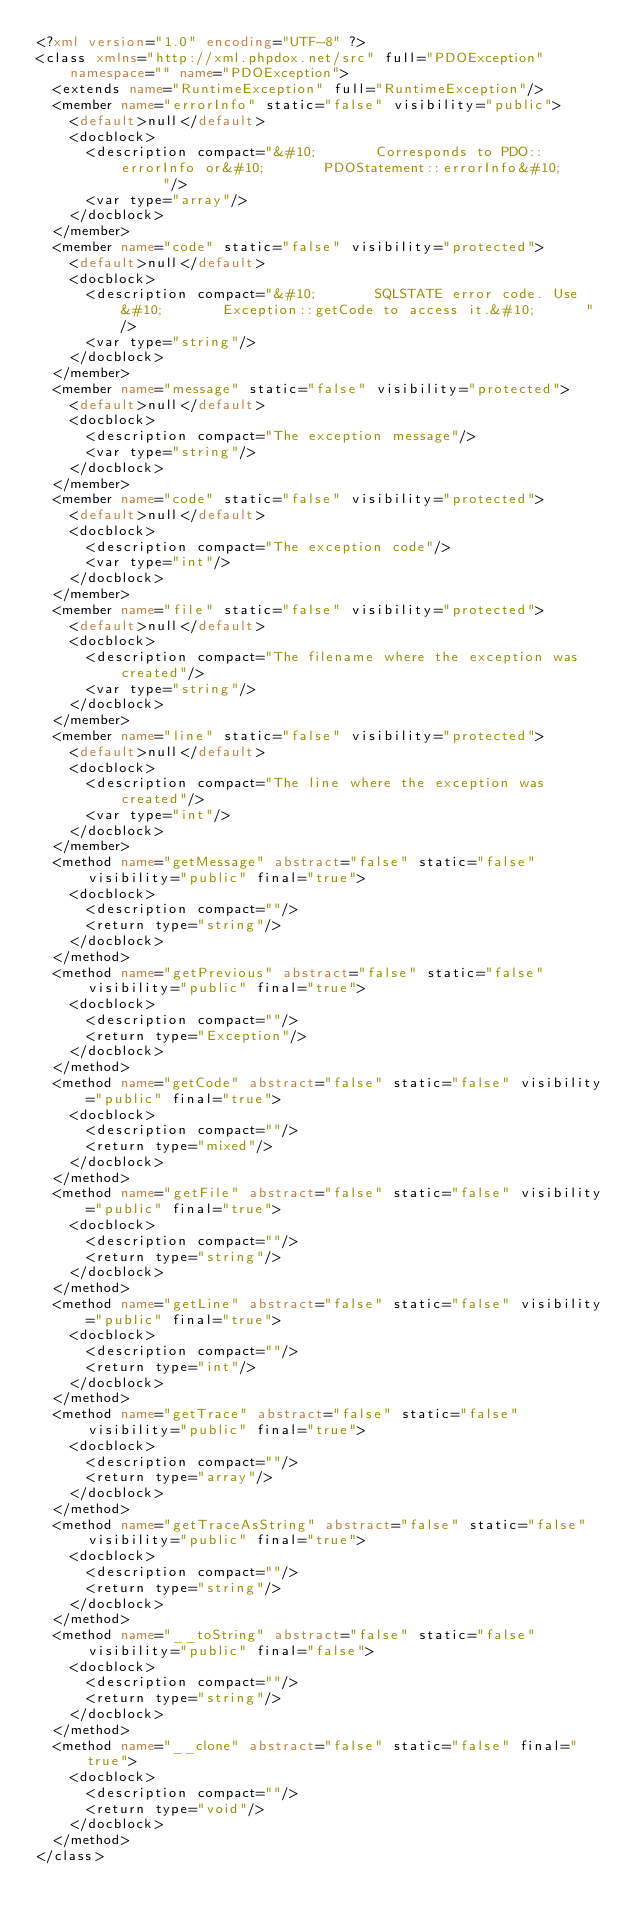Convert code to text. <code><loc_0><loc_0><loc_500><loc_500><_XML_><?xml version="1.0" encoding="UTF-8" ?>
<class xmlns="http://xml.phpdox.net/src" full="PDOException" namespace="" name="PDOException">
  <extends name="RuntimeException" full="RuntimeException"/>
  <member name="errorInfo" static="false" visibility="public">
    <default>null</default>
    <docblock>
      <description compact="&#10;       Corresponds to PDO::errorInfo or&#10;       PDOStatement::errorInfo&#10;      "/>
      <var type="array"/>
    </docblock>
  </member>
  <member name="code" static="false" visibility="protected">
    <default>null</default>
    <docblock>
      <description compact="&#10;       SQLSTATE error code. Use&#10;       Exception::getCode to access it.&#10;      "/>
      <var type="string"/>
    </docblock>
  </member>
  <member name="message" static="false" visibility="protected">
    <default>null</default>
    <docblock>
      <description compact="The exception message"/>
      <var type="string"/>
    </docblock>
  </member>
  <member name="code" static="false" visibility="protected">
    <default>null</default>
    <docblock>
      <description compact="The exception code"/>
      <var type="int"/>
    </docblock>
  </member>
  <member name="file" static="false" visibility="protected">
    <default>null</default>
    <docblock>
      <description compact="The filename where the exception was created"/>
      <var type="string"/>
    </docblock>
  </member>
  <member name="line" static="false" visibility="protected">
    <default>null</default>
    <docblock>
      <description compact="The line where the exception was created"/>
      <var type="int"/>
    </docblock>
  </member>
  <method name="getMessage" abstract="false" static="false" visibility="public" final="true">
    <docblock>
      <description compact=""/>
      <return type="string"/>
    </docblock>
  </method>
  <method name="getPrevious" abstract="false" static="false" visibility="public" final="true">
    <docblock>
      <description compact=""/>
      <return type="Exception"/>
    </docblock>
  </method>
  <method name="getCode" abstract="false" static="false" visibility="public" final="true">
    <docblock>
      <description compact=""/>
      <return type="mixed"/>
    </docblock>
  </method>
  <method name="getFile" abstract="false" static="false" visibility="public" final="true">
    <docblock>
      <description compact=""/>
      <return type="string"/>
    </docblock>
  </method>
  <method name="getLine" abstract="false" static="false" visibility="public" final="true">
    <docblock>
      <description compact=""/>
      <return type="int"/>
    </docblock>
  </method>
  <method name="getTrace" abstract="false" static="false" visibility="public" final="true">
    <docblock>
      <description compact=""/>
      <return type="array"/>
    </docblock>
  </method>
  <method name="getTraceAsString" abstract="false" static="false" visibility="public" final="true">
    <docblock>
      <description compact=""/>
      <return type="string"/>
    </docblock>
  </method>
  <method name="__toString" abstract="false" static="false" visibility="public" final="false">
    <docblock>
      <description compact=""/>
      <return type="string"/>
    </docblock>
  </method>
  <method name="__clone" abstract="false" static="false" final="true">
    <docblock>
      <description compact=""/>
      <return type="void"/>
    </docblock>
  </method>
</class></code> 